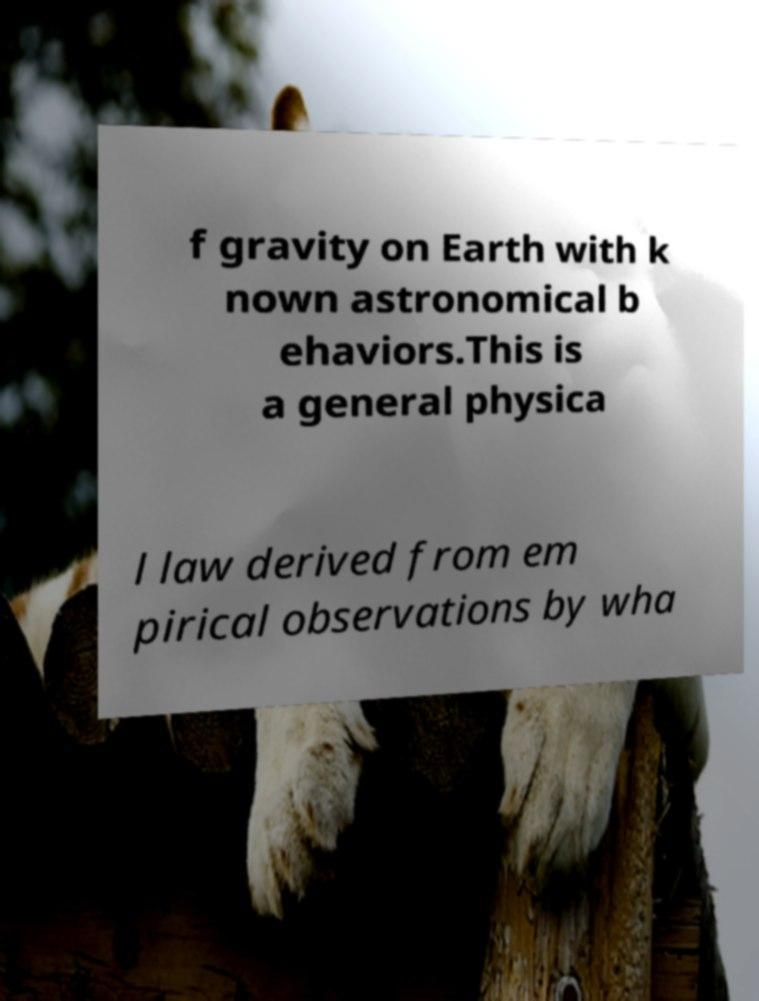Please read and relay the text visible in this image. What does it say? f gravity on Earth with k nown astronomical b ehaviors.This is a general physica l law derived from em pirical observations by wha 